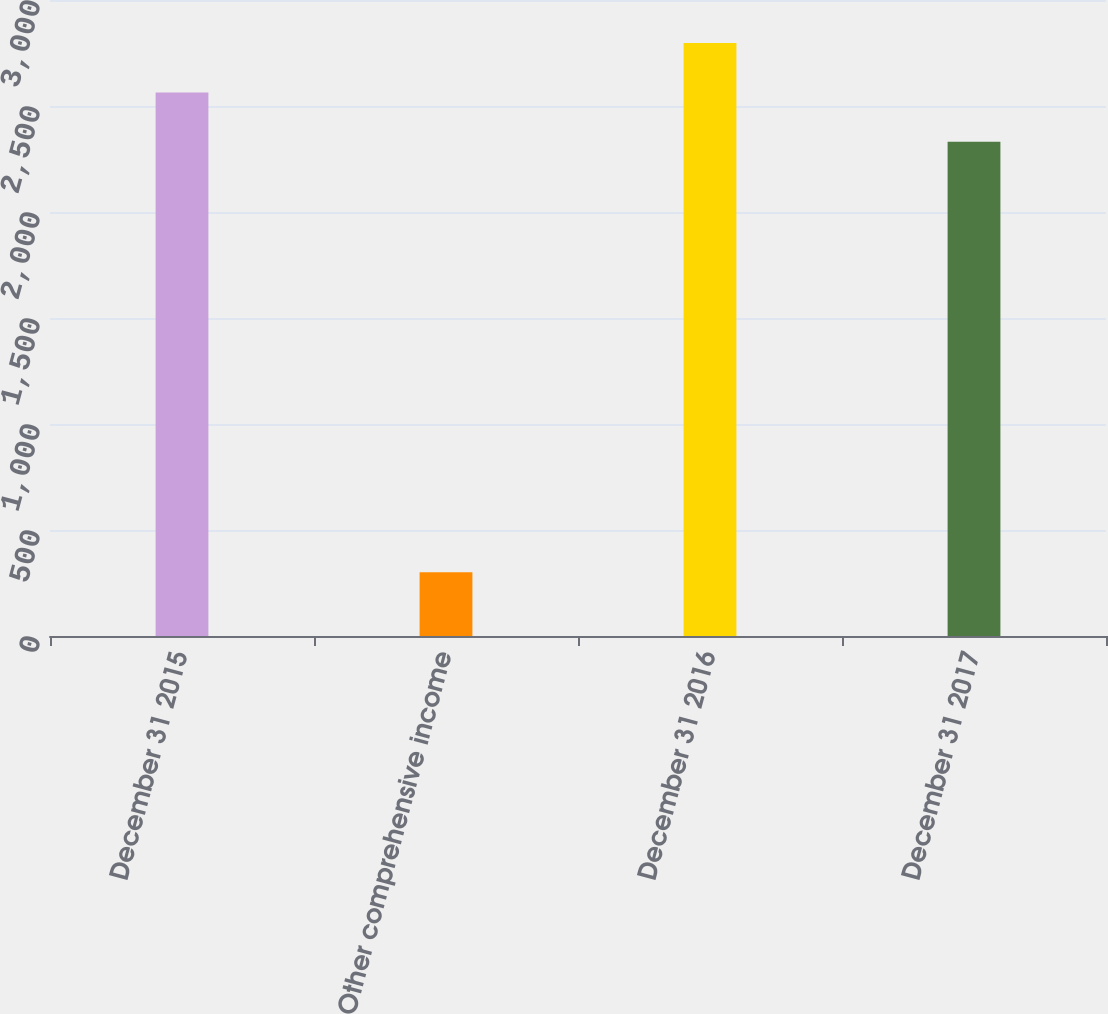<chart> <loc_0><loc_0><loc_500><loc_500><bar_chart><fcel>December 31 2015<fcel>Other comprehensive income<fcel>December 31 2016<fcel>December 31 2017<nl><fcel>2564.2<fcel>301.2<fcel>2797.4<fcel>2331<nl></chart> 